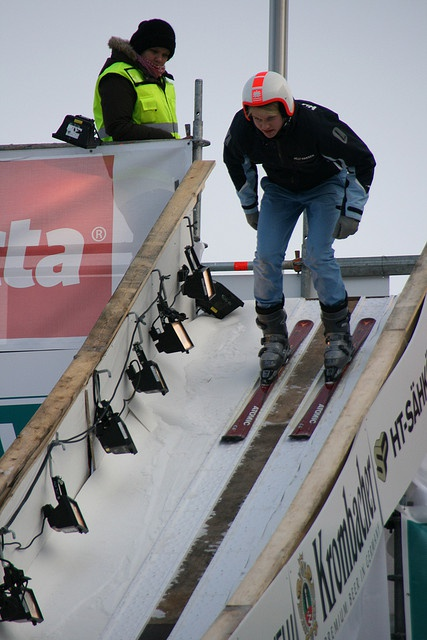Describe the objects in this image and their specific colors. I can see people in darkgray, black, blue, navy, and gray tones, people in darkgray, black, lightgreen, and olive tones, and skis in darkgray, black, gray, and purple tones in this image. 